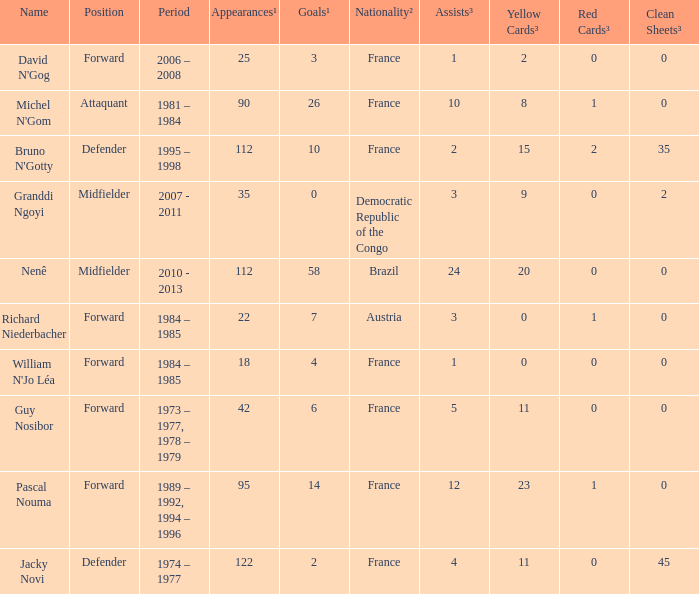I'm looking to parse the entire table for insights. Could you assist me with that? {'header': ['Name', 'Position', 'Period', 'Appearances¹', 'Goals¹', 'Nationality²', 'Assists³', 'Yellow Cards³', 'Red Cards³', 'Clean Sheets³'], 'rows': [["David N'Gog", 'Forward', '2006 – 2008', '25', '3', 'France', '1', '2', '0', '0'], ["Michel N'Gom", 'Attaquant', '1981 – 1984', '90', '26', 'France', '10', '8', '1', '0'], ["Bruno N'Gotty", 'Defender', '1995 – 1998', '112', '10', 'France', '2', '15', '2', '35'], ['Granddi Ngoyi', 'Midfielder', '2007 - 2011', '35', '0', 'Democratic Republic of the Congo', '3', '9', '0', '2'], ['Nenê', 'Midfielder', '2010 - 2013', '112', '58', 'Brazil', '24', '20', '0', '0'], ['Richard Niederbacher', 'Forward', '1984 – 1985', '22', '7', 'Austria', '3', '0', '1', '0'], ["William N'Jo Léa", 'Forward', '1984 – 1985', '18', '4', 'France', '1', '0', '0', '0'], ['Guy Nosibor', 'Forward', '1973 – 1977, 1978 – 1979', '42', '6', 'France', '5', '11', '0', '0'], ['Pascal Nouma', 'Forward', '1989 – 1992, 1994 – 1996', '95', '14', 'France', '12', '23', '1', '0'], ['Jacky Novi', 'Defender', '1974 – 1977', '122', '2', 'France', '4', '11', '0', '45']]} How many games had less than 7 goals scored? 1.0. 